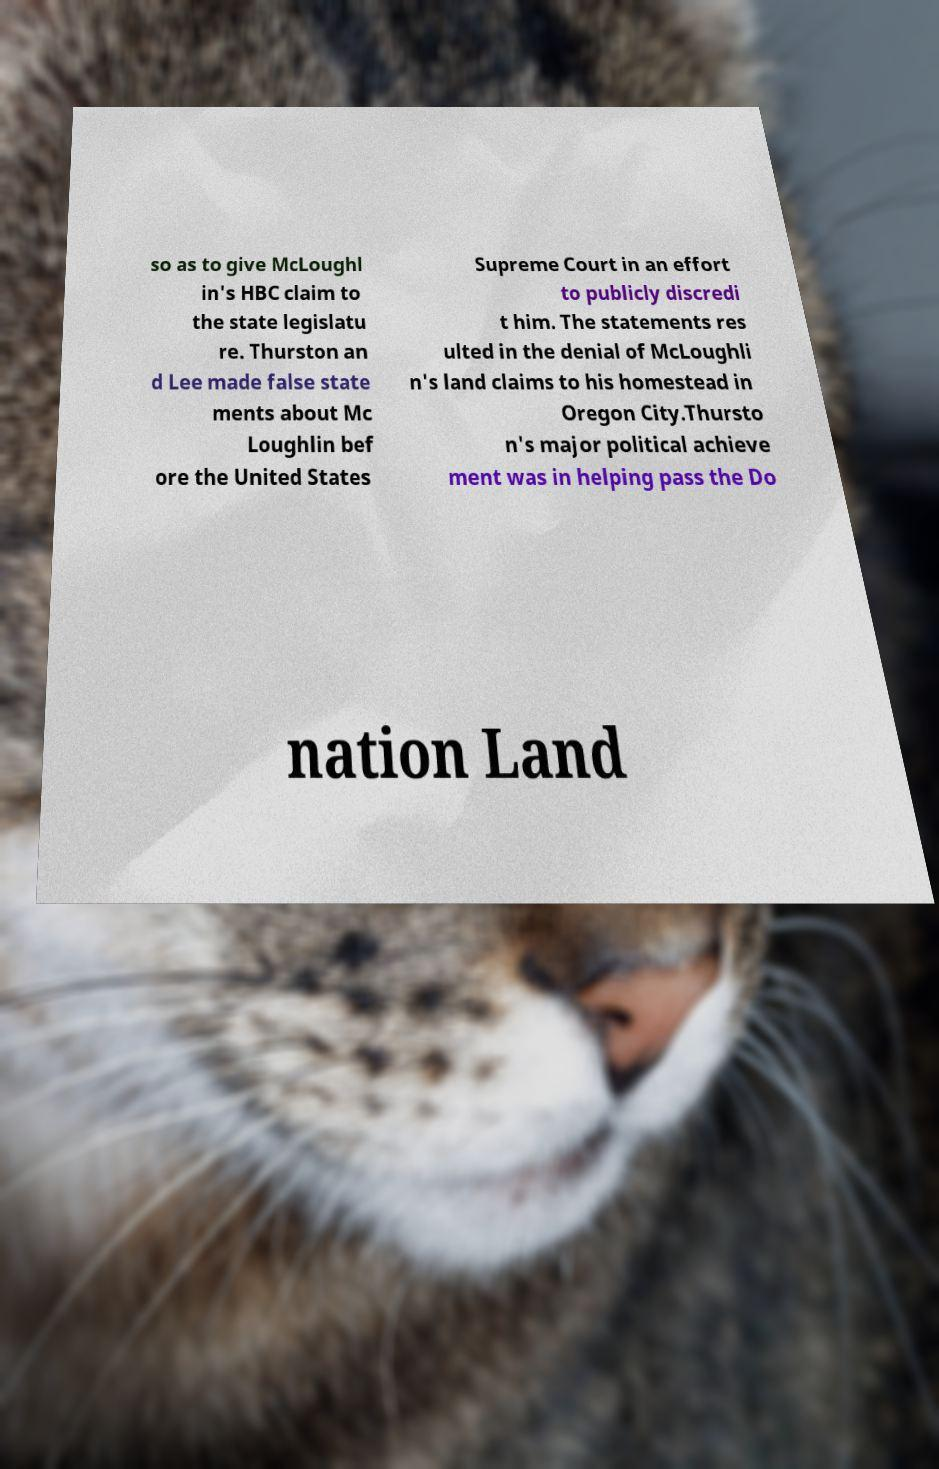Please identify and transcribe the text found in this image. so as to give McLoughl in's HBC claim to the state legislatu re. Thurston an d Lee made false state ments about Mc Loughlin bef ore the United States Supreme Court in an effort to publicly discredi t him. The statements res ulted in the denial of McLoughli n's land claims to his homestead in Oregon City.Thursto n's major political achieve ment was in helping pass the Do nation Land 